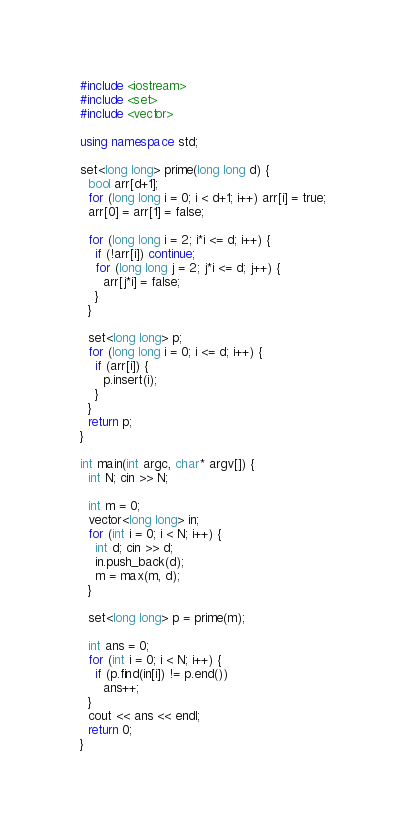<code> <loc_0><loc_0><loc_500><loc_500><_C++_>#include <iostream>
#include <set>
#include <vector>

using namespace std;

set<long long> prime(long long d) {
  bool arr[d+1];
  for (long long i = 0; i < d+1; i++) arr[i] = true;
  arr[0] = arr[1] = false;

  for (long long i = 2; i*i <= d; i++) {
    if (!arr[i]) continue;
    for (long long j = 2; j*i <= d; j++) {
      arr[j*i] = false;
    }
  }

  set<long long> p;
  for (long long i = 0; i <= d; i++) {
    if (arr[i]) {
      p.insert(i);
    }
  }
  return p;
}

int main(int argc, char* argv[]) {
  int N; cin >> N;

  int m = 0;
  vector<long long> in;
  for (int i = 0; i < N; i++) {
    int d; cin >> d;
    in.push_back(d);
    m = max(m, d);
  }

  set<long long> p = prime(m);

  int ans = 0;
  for (int i = 0; i < N; i++) {
    if (p.find(in[i]) != p.end())
      ans++;
  }
  cout << ans << endl;
  return 0;
}</code> 